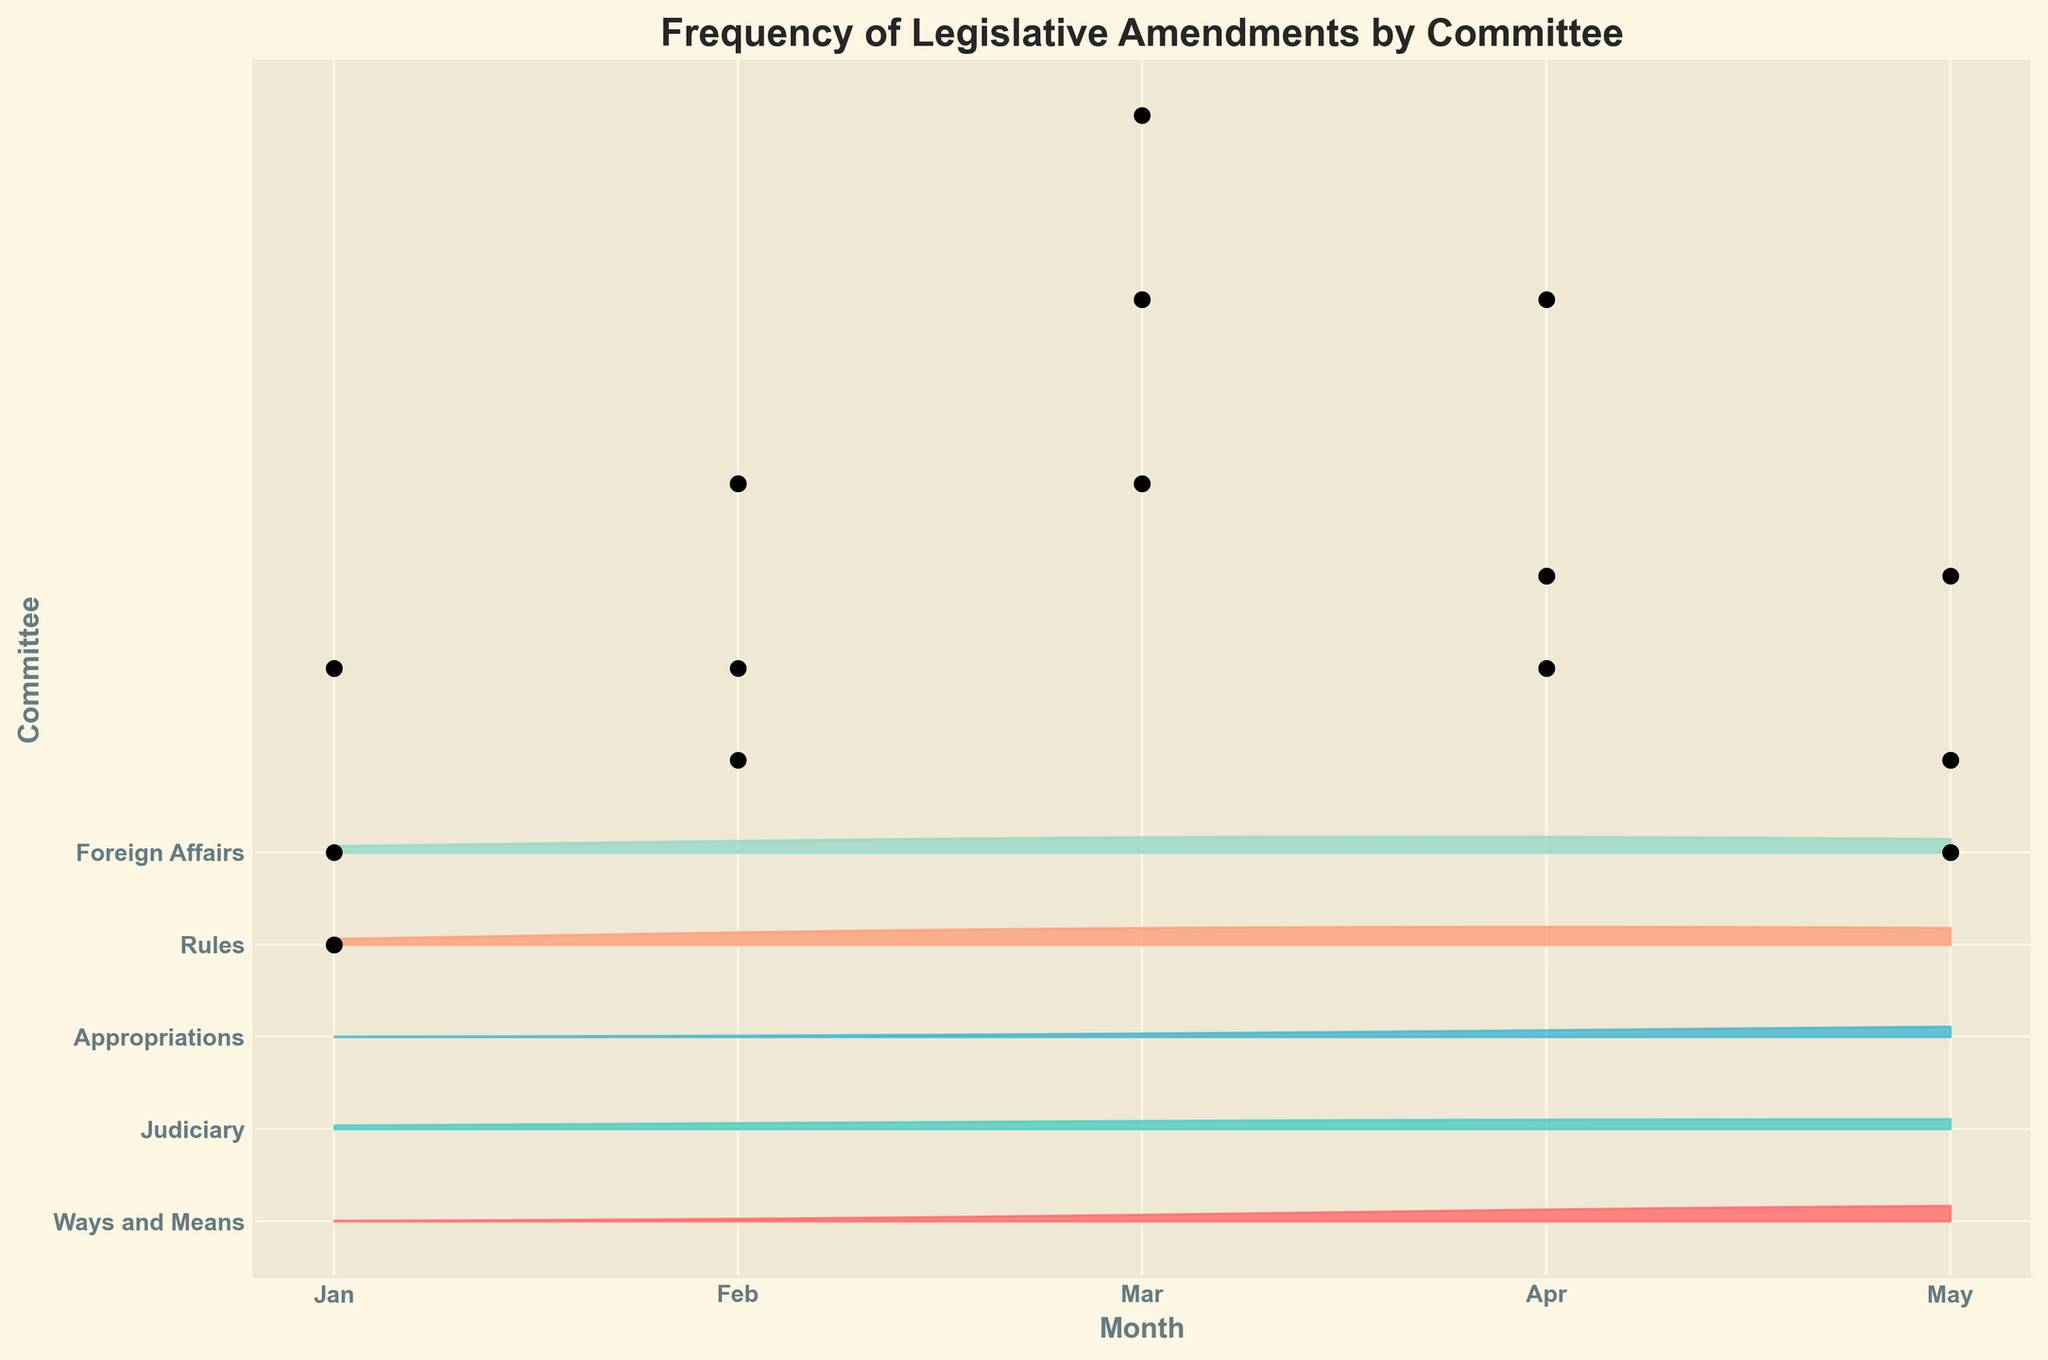How many committees are displayed in the plot? The plot shows one ridgeline for each unique committee. Count the distinct ridgelines or the labels on the y-axis.
Answer: 5 Which committee had the highest amendment frequency in March? Look for the peak in March on the ridgeline plot. Check the y-axis label corresponding to that ridgeline section.
Answer: Appropriations Which month showed the lowest amendment frequency for the Foreign Affairs committee? Follow the Foreign Affairs committee ridgeline from January to May and identify the lowest point.
Answer: May Comparing the Ways and Means and Judiciary committees, which had more amendments in April? Check the ridgeline peaks for both committees in April and compare the heights.
Answer: Ways and Means What is the total number of amendments proposed by the Rules committee from Jan to May? Sum the amendment counts for the Rules committee across all months.
Answer: 15 Which committee had the most variable amendment frequencies over the months? Identify the committee with the most fluctuation in the heights of its ridgeline.
Answer: Judiciary For the Appropriations committee, in which months did the amendment frequency exceed 6? Check the peaks for the Appropriations committee and note the months exceeding the height of 6.
Answer: February, March, April How do the peaks of foreign affairs and rules committee compare in March? Compare the heights of the Foreign Affairs and Rules committee ridgelines in March.
Answer: Foreign Affairs is higher 